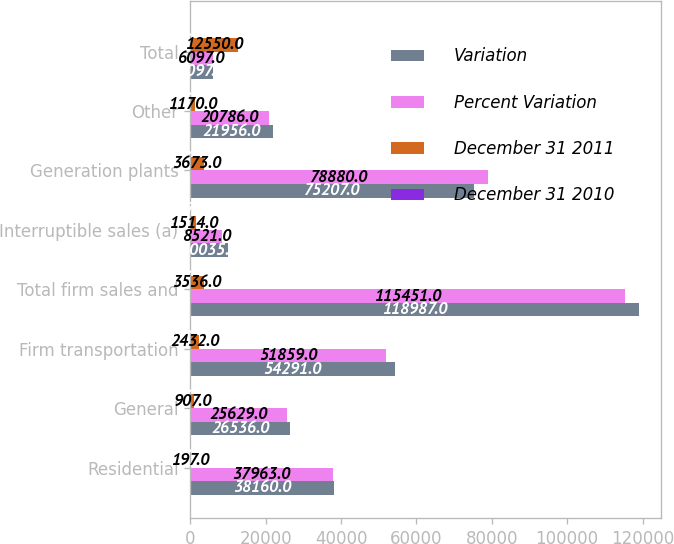<chart> <loc_0><loc_0><loc_500><loc_500><stacked_bar_chart><ecel><fcel>Residential<fcel>General<fcel>Firm transportation<fcel>Total firm sales and<fcel>Interruptible sales (a)<fcel>Generation plants<fcel>Other<fcel>Total<nl><fcel>Variation<fcel>38160<fcel>26536<fcel>54291<fcel>118987<fcel>10035<fcel>75207<fcel>21956<fcel>6097<nl><fcel>Percent Variation<fcel>37963<fcel>25629<fcel>51859<fcel>115451<fcel>8521<fcel>78880<fcel>20786<fcel>6097<nl><fcel>December 31 2011<fcel>197<fcel>907<fcel>2432<fcel>3536<fcel>1514<fcel>3673<fcel>1170<fcel>12550<nl><fcel>December 31 2010<fcel>0.5<fcel>3.5<fcel>4.7<fcel>3.1<fcel>17.8<fcel>4.7<fcel>5.6<fcel>5<nl></chart> 